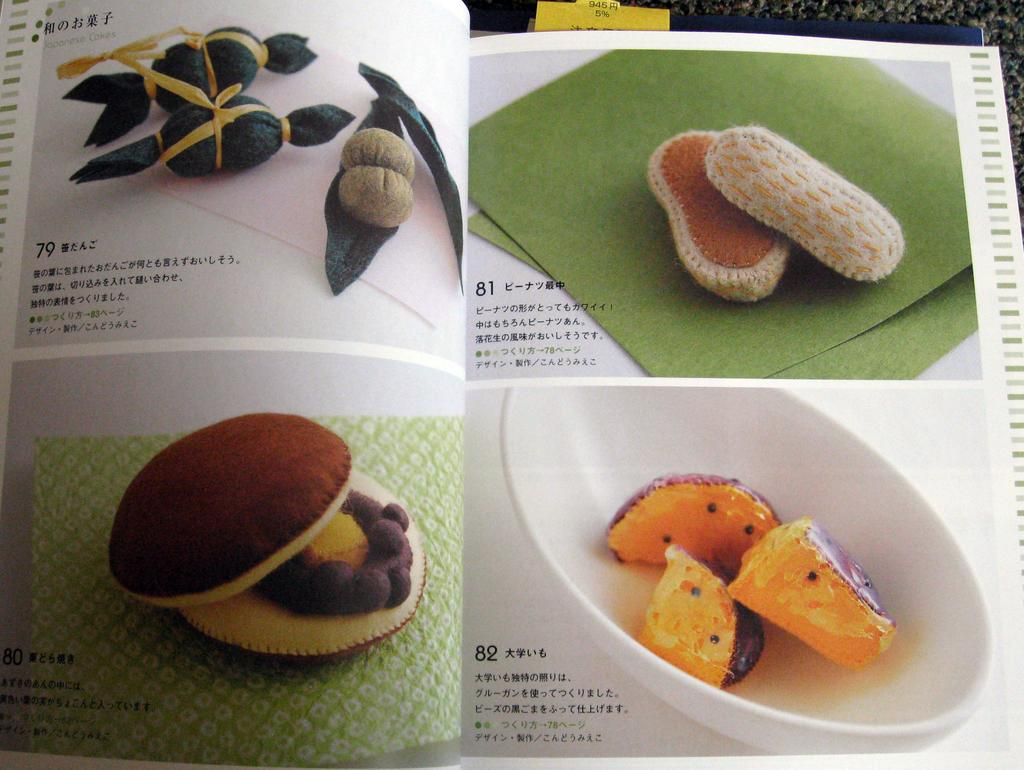What is the main object in the foreground of the image? There is a book in the foreground of the image. What type of content does the book contain? The book contains text. What specific items can be found within the book? There are doughnuts, bowls, and other food items in the book. What type of punishment is being depicted in the image? There is no punishment being depicted in the image; it features a book with text and various food items. Can you provide an example of a recipe found in the book? The image does not provide enough information to give an example of a recipe, as it only shows the book's contents and not the actual text. 